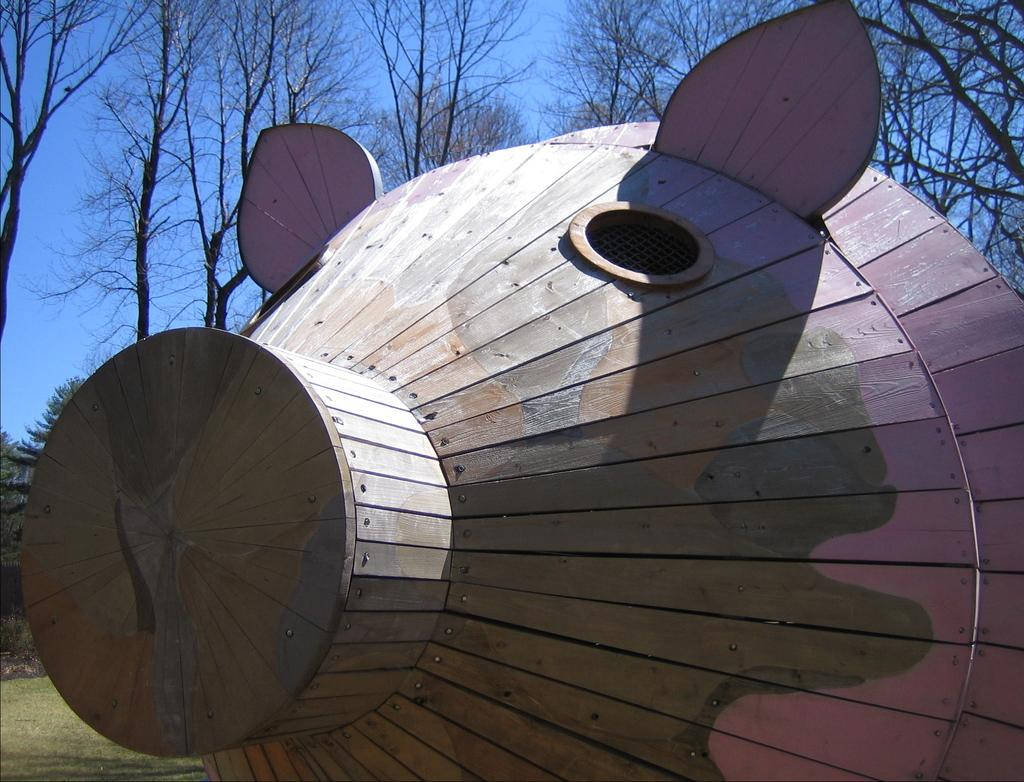What type of wooden object is in the image? There is a wooden object in the image, but its specific type cannot be determined from the provided facts. What can be seen in the background of the image? There are trees and the sky visible in the background of the image. Can you see any parent dinosaurs taking their baby dinosaurs to meet a lawyer in the image? There is no reference to dinosaurs, parents, baby dinosaurs, or lawyers in the image. 